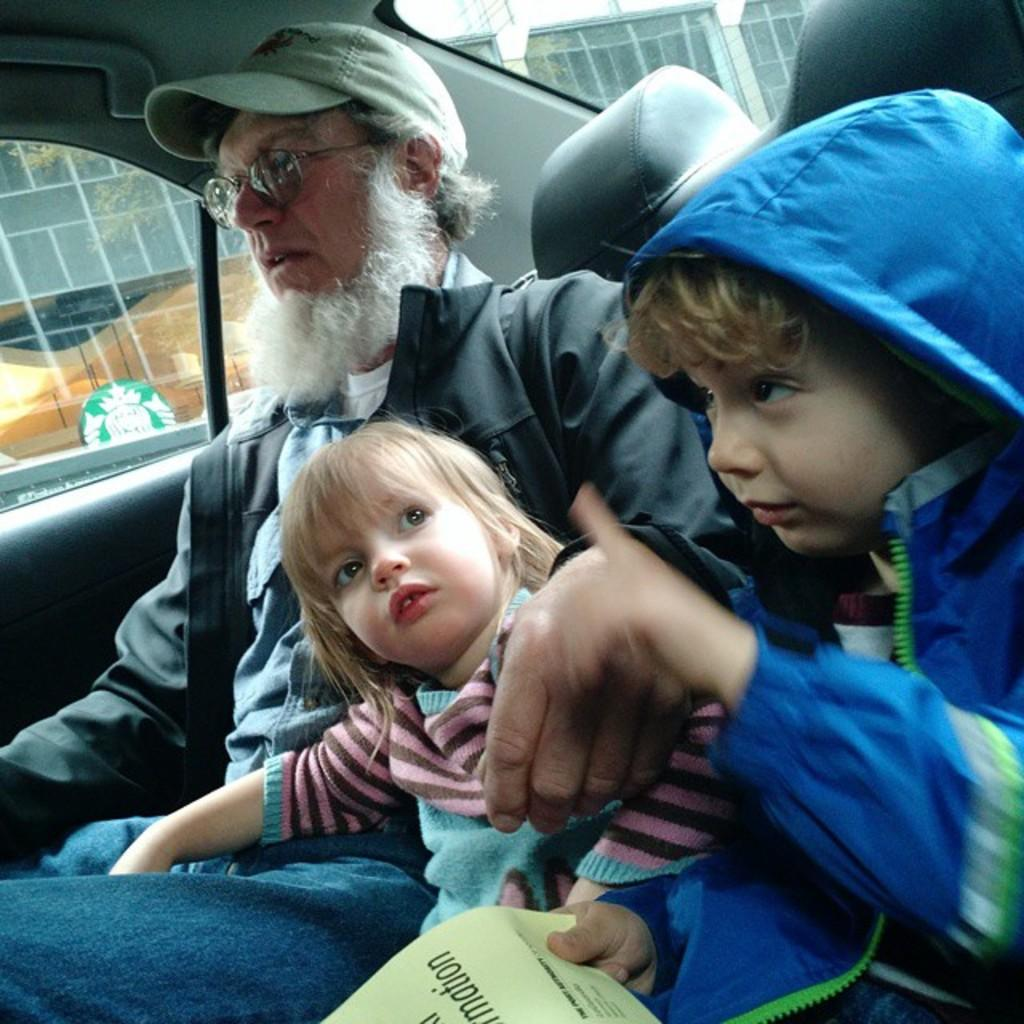What is happening in the image? There is a group of people in the image, and they are sitting in a car. Can you describe the members of the group? There is a man, a boy, and a girl in the group. What is the gender of the people in the group? The group consists of one man and two children, one boy and one girl. What type of quiver is the man holding in the image? There is no quiver present in the image; the man is sitting in a car with the other people. 